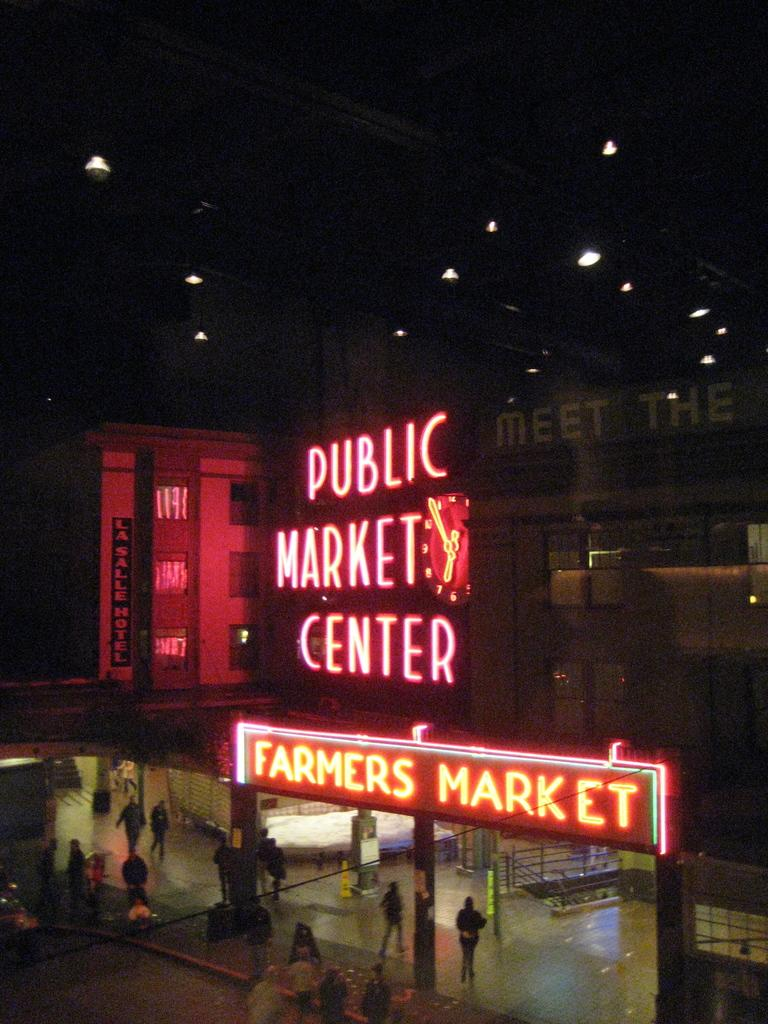What type of structures are present in the image? There are buildings in the image. What additional information can be found on the buildings? There are names on the buildings. What can be seen in the background of the image? There are lights visible in the background. Who or what is present on the ground in the image? There are people standing on the ground in the image. What type of mask is being worn by the people in the image? There are no masks visible in the image; the people are not wearing any masks. What type of material are the houses made of in the image? There are no houses present in the image, only buildings. 